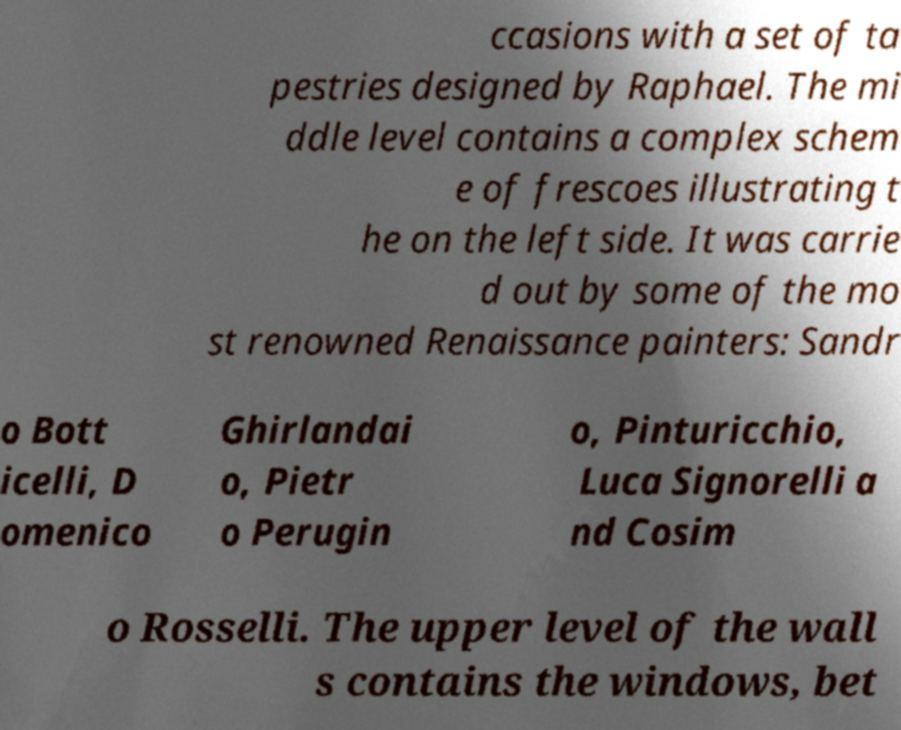There's text embedded in this image that I need extracted. Can you transcribe it verbatim? ccasions with a set of ta pestries designed by Raphael. The mi ddle level contains a complex schem e of frescoes illustrating t he on the left side. It was carrie d out by some of the mo st renowned Renaissance painters: Sandr o Bott icelli, D omenico Ghirlandai o, Pietr o Perugin o, Pinturicchio, Luca Signorelli a nd Cosim o Rosselli. The upper level of the wall s contains the windows, bet 